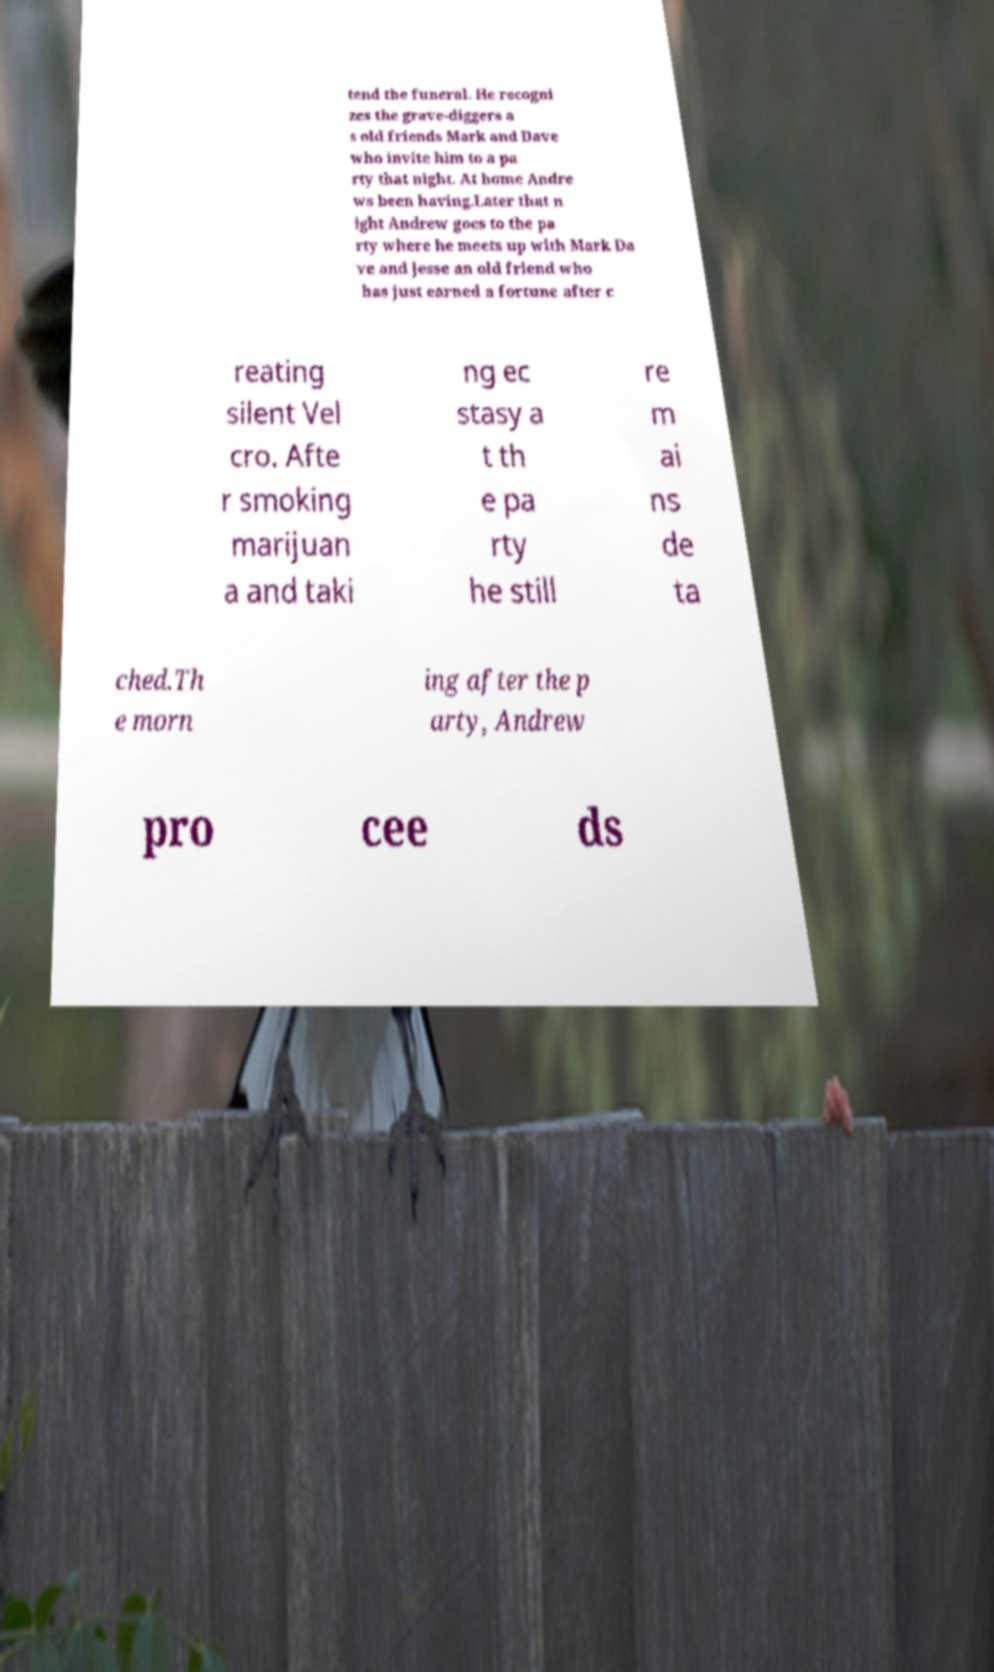What messages or text are displayed in this image? I need them in a readable, typed format. tend the funeral. He recogni zes the grave-diggers a s old friends Mark and Dave who invite him to a pa rty that night. At home Andre ws been having.Later that n ight Andrew goes to the pa rty where he meets up with Mark Da ve and Jesse an old friend who has just earned a fortune after c reating silent Vel cro. Afte r smoking marijuan a and taki ng ec stasy a t th e pa rty he still re m ai ns de ta ched.Th e morn ing after the p arty, Andrew pro cee ds 